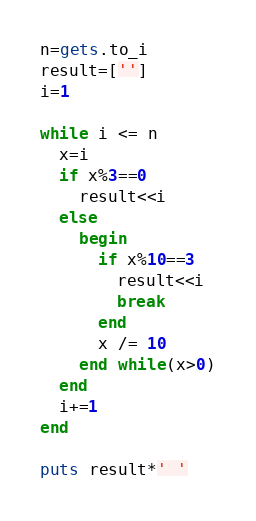<code> <loc_0><loc_0><loc_500><loc_500><_Ruby_>n=gets.to_i
result=['']
i=1

while i <= n
  x=i
  if x%3==0
    result<<i
  else
    begin
      if x%10==3
        result<<i
        break
      end
      x /= 10
    end while(x>0)
  end
  i+=1
end

puts result*' '</code> 